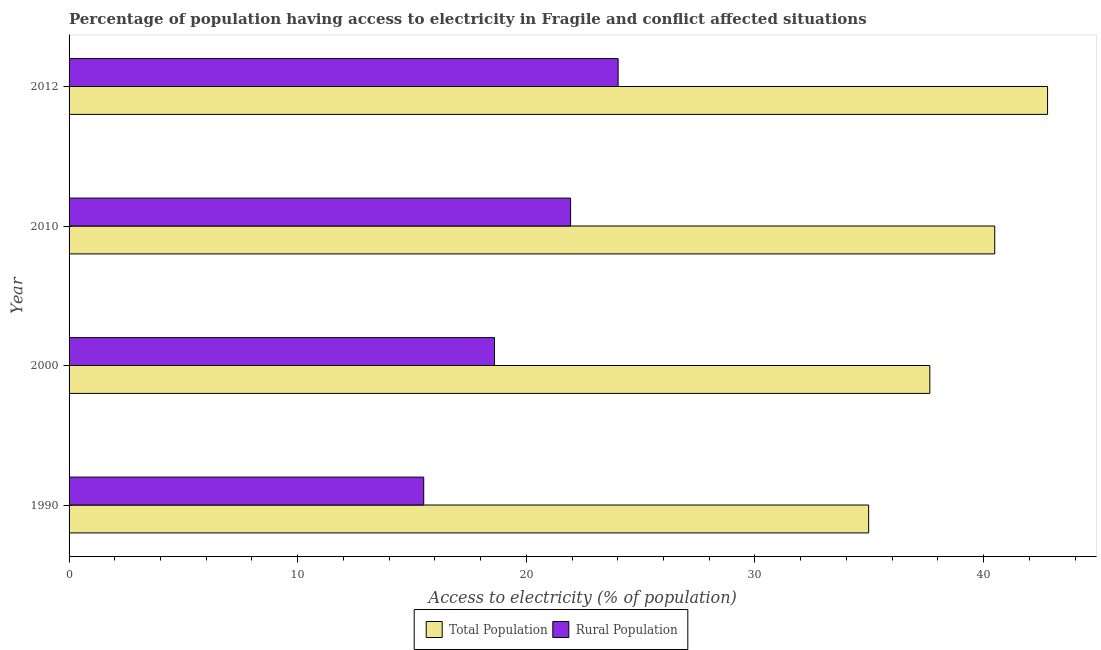Are the number of bars per tick equal to the number of legend labels?
Keep it short and to the point. Yes. How many bars are there on the 4th tick from the bottom?
Make the answer very short. 2. In how many cases, is the number of bars for a given year not equal to the number of legend labels?
Ensure brevity in your answer.  0. What is the percentage of rural population having access to electricity in 2000?
Your answer should be compact. 18.61. Across all years, what is the maximum percentage of population having access to electricity?
Make the answer very short. 42.8. Across all years, what is the minimum percentage of rural population having access to electricity?
Ensure brevity in your answer.  15.51. What is the total percentage of population having access to electricity in the graph?
Your answer should be very brief. 155.91. What is the difference between the percentage of rural population having access to electricity in 1990 and that in 2000?
Ensure brevity in your answer.  -3.1. What is the difference between the percentage of population having access to electricity in 2000 and the percentage of rural population having access to electricity in 2010?
Keep it short and to the point. 15.71. What is the average percentage of population having access to electricity per year?
Your answer should be compact. 38.98. In the year 2010, what is the difference between the percentage of population having access to electricity and percentage of rural population having access to electricity?
Your answer should be very brief. 18.55. In how many years, is the percentage of rural population having access to electricity greater than 26 %?
Ensure brevity in your answer.  0. What is the ratio of the percentage of population having access to electricity in 1990 to that in 2010?
Ensure brevity in your answer.  0.86. Is the percentage of rural population having access to electricity in 2000 less than that in 2010?
Give a very brief answer. Yes. Is the difference between the percentage of population having access to electricity in 2000 and 2010 greater than the difference between the percentage of rural population having access to electricity in 2000 and 2010?
Keep it short and to the point. Yes. What is the difference between the highest and the second highest percentage of rural population having access to electricity?
Provide a succinct answer. 2.08. What is the difference between the highest and the lowest percentage of population having access to electricity?
Make the answer very short. 7.83. In how many years, is the percentage of rural population having access to electricity greater than the average percentage of rural population having access to electricity taken over all years?
Make the answer very short. 2. Is the sum of the percentage of rural population having access to electricity in 2010 and 2012 greater than the maximum percentage of population having access to electricity across all years?
Make the answer very short. Yes. What does the 1st bar from the top in 2012 represents?
Your answer should be compact. Rural Population. What does the 1st bar from the bottom in 2010 represents?
Offer a terse response. Total Population. Are all the bars in the graph horizontal?
Offer a terse response. Yes. Does the graph contain any zero values?
Give a very brief answer. No. How many legend labels are there?
Your answer should be very brief. 2. How are the legend labels stacked?
Ensure brevity in your answer.  Horizontal. What is the title of the graph?
Ensure brevity in your answer.  Percentage of population having access to electricity in Fragile and conflict affected situations. What is the label or title of the X-axis?
Provide a succinct answer. Access to electricity (% of population). What is the Access to electricity (% of population) in Total Population in 1990?
Provide a succinct answer. 34.97. What is the Access to electricity (% of population) of Rural Population in 1990?
Give a very brief answer. 15.51. What is the Access to electricity (% of population) in Total Population in 2000?
Give a very brief answer. 37.65. What is the Access to electricity (% of population) of Rural Population in 2000?
Your answer should be compact. 18.61. What is the Access to electricity (% of population) in Total Population in 2010?
Offer a very short reply. 40.49. What is the Access to electricity (% of population) in Rural Population in 2010?
Give a very brief answer. 21.94. What is the Access to electricity (% of population) of Total Population in 2012?
Offer a very short reply. 42.8. What is the Access to electricity (% of population) of Rural Population in 2012?
Make the answer very short. 24.01. Across all years, what is the maximum Access to electricity (% of population) of Total Population?
Offer a terse response. 42.8. Across all years, what is the maximum Access to electricity (% of population) in Rural Population?
Provide a short and direct response. 24.01. Across all years, what is the minimum Access to electricity (% of population) in Total Population?
Your response must be concise. 34.97. Across all years, what is the minimum Access to electricity (% of population) in Rural Population?
Give a very brief answer. 15.51. What is the total Access to electricity (% of population) of Total Population in the graph?
Your response must be concise. 155.91. What is the total Access to electricity (% of population) in Rural Population in the graph?
Offer a very short reply. 80.07. What is the difference between the Access to electricity (% of population) of Total Population in 1990 and that in 2000?
Provide a succinct answer. -2.68. What is the difference between the Access to electricity (% of population) of Rural Population in 1990 and that in 2000?
Provide a short and direct response. -3.1. What is the difference between the Access to electricity (% of population) in Total Population in 1990 and that in 2010?
Make the answer very short. -5.51. What is the difference between the Access to electricity (% of population) in Rural Population in 1990 and that in 2010?
Your answer should be compact. -6.42. What is the difference between the Access to electricity (% of population) in Total Population in 1990 and that in 2012?
Ensure brevity in your answer.  -7.83. What is the difference between the Access to electricity (% of population) of Rural Population in 1990 and that in 2012?
Provide a short and direct response. -8.5. What is the difference between the Access to electricity (% of population) of Total Population in 2000 and that in 2010?
Provide a short and direct response. -2.84. What is the difference between the Access to electricity (% of population) of Rural Population in 2000 and that in 2010?
Your answer should be compact. -3.33. What is the difference between the Access to electricity (% of population) in Total Population in 2000 and that in 2012?
Offer a terse response. -5.15. What is the difference between the Access to electricity (% of population) of Rural Population in 2000 and that in 2012?
Your response must be concise. -5.41. What is the difference between the Access to electricity (% of population) in Total Population in 2010 and that in 2012?
Your response must be concise. -2.31. What is the difference between the Access to electricity (% of population) in Rural Population in 2010 and that in 2012?
Keep it short and to the point. -2.08. What is the difference between the Access to electricity (% of population) of Total Population in 1990 and the Access to electricity (% of population) of Rural Population in 2000?
Offer a very short reply. 16.36. What is the difference between the Access to electricity (% of population) of Total Population in 1990 and the Access to electricity (% of population) of Rural Population in 2010?
Provide a succinct answer. 13.04. What is the difference between the Access to electricity (% of population) of Total Population in 1990 and the Access to electricity (% of population) of Rural Population in 2012?
Your response must be concise. 10.96. What is the difference between the Access to electricity (% of population) in Total Population in 2000 and the Access to electricity (% of population) in Rural Population in 2010?
Ensure brevity in your answer.  15.71. What is the difference between the Access to electricity (% of population) of Total Population in 2000 and the Access to electricity (% of population) of Rural Population in 2012?
Your answer should be very brief. 13.63. What is the difference between the Access to electricity (% of population) in Total Population in 2010 and the Access to electricity (% of population) in Rural Population in 2012?
Give a very brief answer. 16.47. What is the average Access to electricity (% of population) in Total Population per year?
Make the answer very short. 38.98. What is the average Access to electricity (% of population) of Rural Population per year?
Offer a very short reply. 20.02. In the year 1990, what is the difference between the Access to electricity (% of population) of Total Population and Access to electricity (% of population) of Rural Population?
Your answer should be very brief. 19.46. In the year 2000, what is the difference between the Access to electricity (% of population) of Total Population and Access to electricity (% of population) of Rural Population?
Your answer should be very brief. 19.04. In the year 2010, what is the difference between the Access to electricity (% of population) of Total Population and Access to electricity (% of population) of Rural Population?
Your answer should be compact. 18.55. In the year 2012, what is the difference between the Access to electricity (% of population) of Total Population and Access to electricity (% of population) of Rural Population?
Provide a succinct answer. 18.78. What is the ratio of the Access to electricity (% of population) of Total Population in 1990 to that in 2000?
Your response must be concise. 0.93. What is the ratio of the Access to electricity (% of population) in Rural Population in 1990 to that in 2000?
Your response must be concise. 0.83. What is the ratio of the Access to electricity (% of population) in Total Population in 1990 to that in 2010?
Your answer should be compact. 0.86. What is the ratio of the Access to electricity (% of population) of Rural Population in 1990 to that in 2010?
Your answer should be compact. 0.71. What is the ratio of the Access to electricity (% of population) of Total Population in 1990 to that in 2012?
Your answer should be very brief. 0.82. What is the ratio of the Access to electricity (% of population) of Rural Population in 1990 to that in 2012?
Keep it short and to the point. 0.65. What is the ratio of the Access to electricity (% of population) of Total Population in 2000 to that in 2010?
Provide a succinct answer. 0.93. What is the ratio of the Access to electricity (% of population) in Rural Population in 2000 to that in 2010?
Ensure brevity in your answer.  0.85. What is the ratio of the Access to electricity (% of population) of Total Population in 2000 to that in 2012?
Your answer should be compact. 0.88. What is the ratio of the Access to electricity (% of population) of Rural Population in 2000 to that in 2012?
Keep it short and to the point. 0.77. What is the ratio of the Access to electricity (% of population) in Total Population in 2010 to that in 2012?
Provide a succinct answer. 0.95. What is the ratio of the Access to electricity (% of population) of Rural Population in 2010 to that in 2012?
Your answer should be very brief. 0.91. What is the difference between the highest and the second highest Access to electricity (% of population) of Total Population?
Offer a terse response. 2.31. What is the difference between the highest and the second highest Access to electricity (% of population) in Rural Population?
Offer a terse response. 2.08. What is the difference between the highest and the lowest Access to electricity (% of population) of Total Population?
Offer a terse response. 7.83. What is the difference between the highest and the lowest Access to electricity (% of population) of Rural Population?
Your response must be concise. 8.5. 